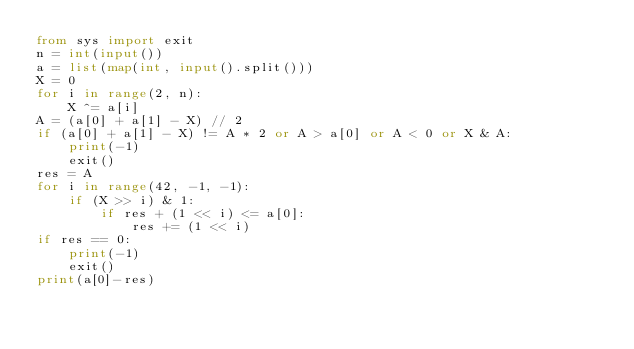Convert code to text. <code><loc_0><loc_0><loc_500><loc_500><_Python_>from sys import exit
n = int(input())
a = list(map(int, input().split()))
X = 0
for i in range(2, n):
	X ^= a[i]
A = (a[0] + a[1] - X) // 2
if (a[0] + a[1] - X) != A * 2 or A > a[0] or A < 0 or X & A: 
	print(-1)
	exit()
res = A
for i in range(42, -1, -1):
	if (X >> i) & 1:
		if res + (1 << i) <= a[0]:
			res += (1 << i)
if res == 0:
	print(-1)
	exit()
print(a[0]-res)</code> 